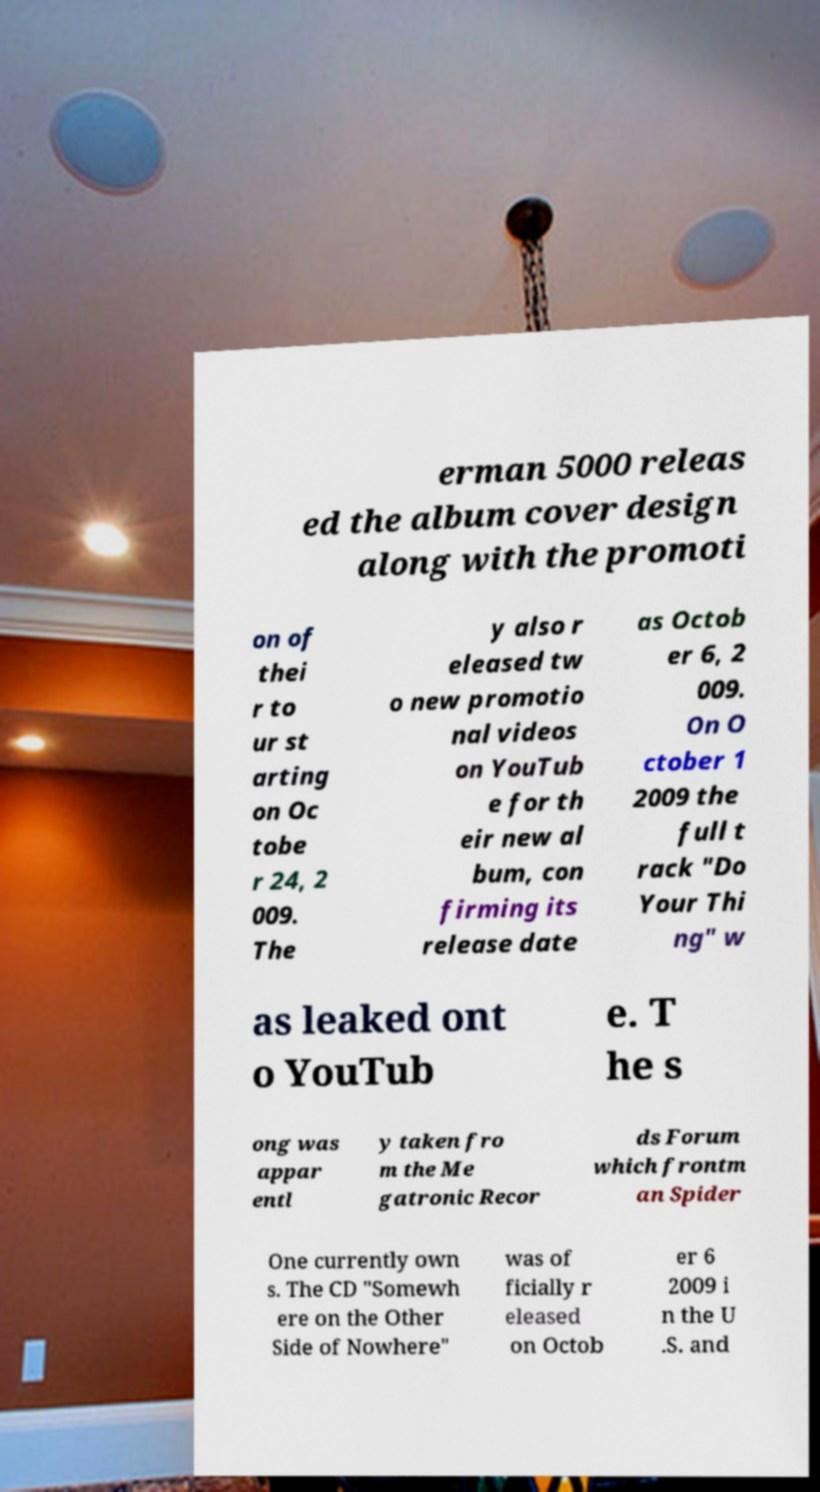Can you read and provide the text displayed in the image?This photo seems to have some interesting text. Can you extract and type it out for me? erman 5000 releas ed the album cover design along with the promoti on of thei r to ur st arting on Oc tobe r 24, 2 009. The y also r eleased tw o new promotio nal videos on YouTub e for th eir new al bum, con firming its release date as Octob er 6, 2 009. On O ctober 1 2009 the full t rack "Do Your Thi ng" w as leaked ont o YouTub e. T he s ong was appar entl y taken fro m the Me gatronic Recor ds Forum which frontm an Spider One currently own s. The CD "Somewh ere on the Other Side of Nowhere" was of ficially r eleased on Octob er 6 2009 i n the U .S. and 